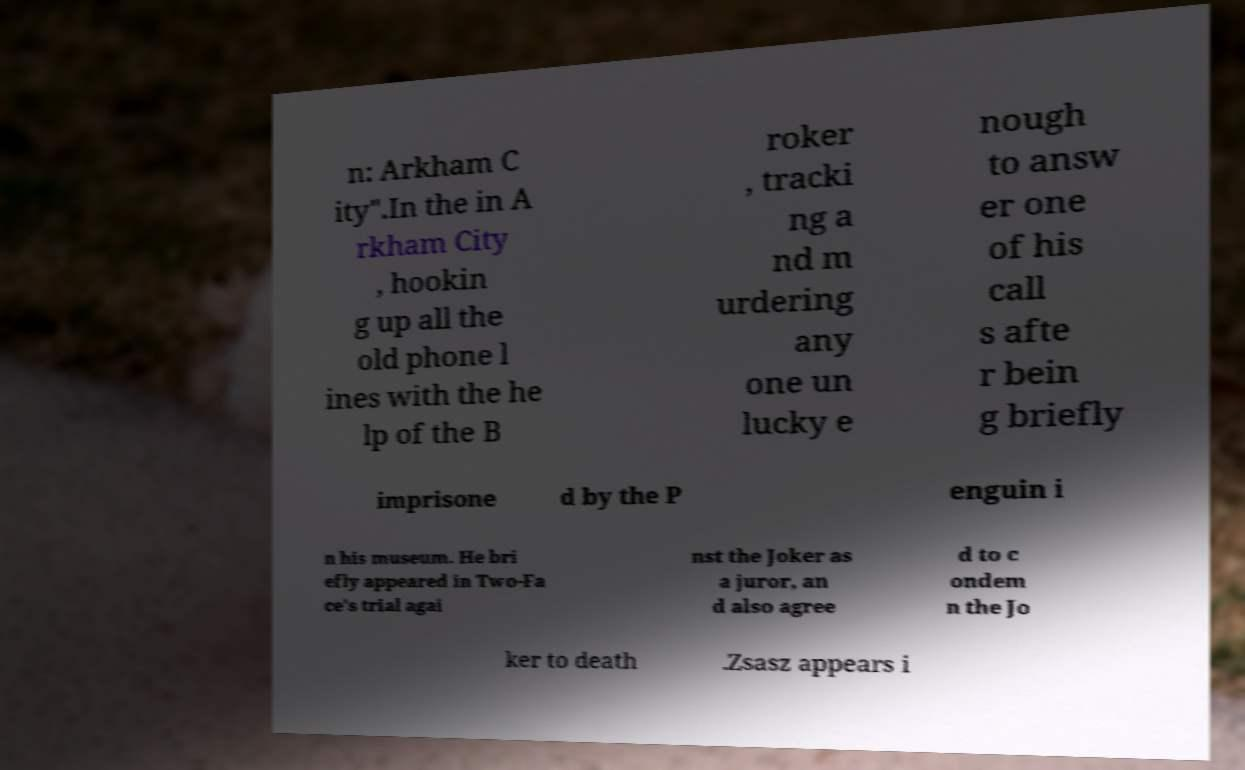Please identify and transcribe the text found in this image. n: Arkham C ity".In the in A rkham City , hookin g up all the old phone l ines with the he lp of the B roker , tracki ng a nd m urdering any one un lucky e nough to answ er one of his call s afte r bein g briefly imprisone d by the P enguin i n his museum. He bri efly appeared in Two-Fa ce's trial agai nst the Joker as a juror, an d also agree d to c ondem n the Jo ker to death .Zsasz appears i 